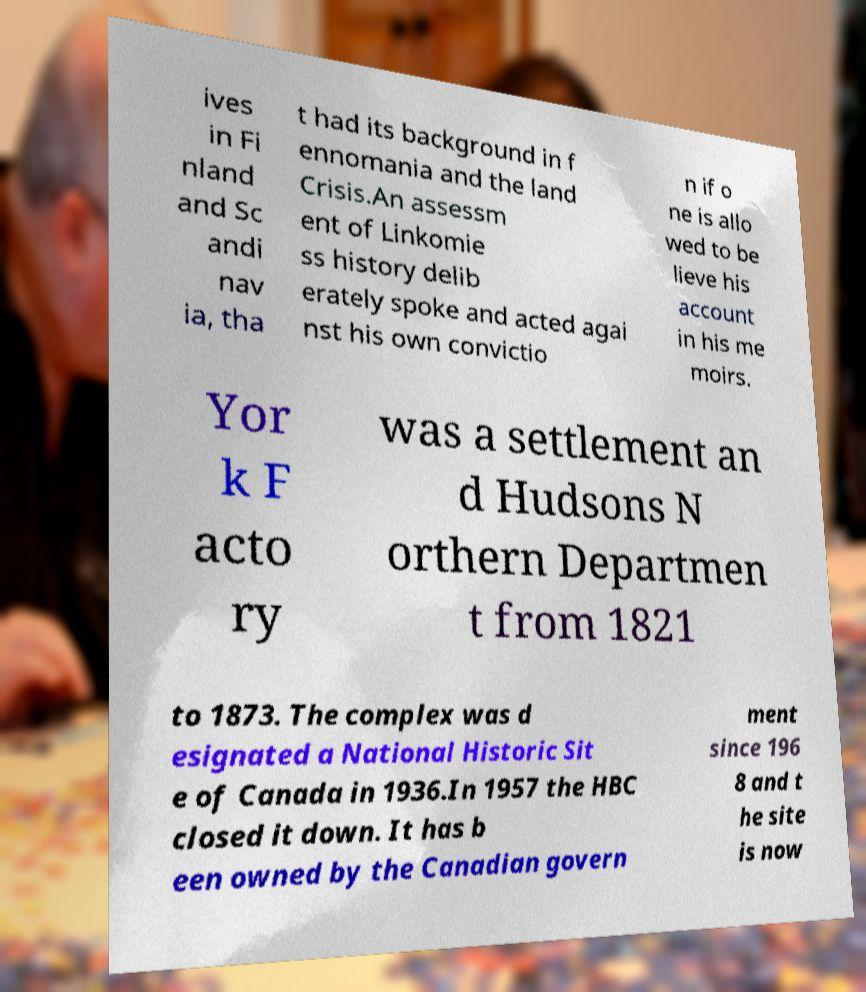What messages or text are displayed in this image? I need them in a readable, typed format. ives in Fi nland and Sc andi nav ia, tha t had its background in f ennomania and the land Crisis.An assessm ent of Linkomie ss history delib erately spoke and acted agai nst his own convictio n if o ne is allo wed to be lieve his account in his me moirs. Yor k F acto ry was a settlement an d Hudsons N orthern Departmen t from 1821 to 1873. The complex was d esignated a National Historic Sit e of Canada in 1936.In 1957 the HBC closed it down. It has b een owned by the Canadian govern ment since 196 8 and t he site is now 